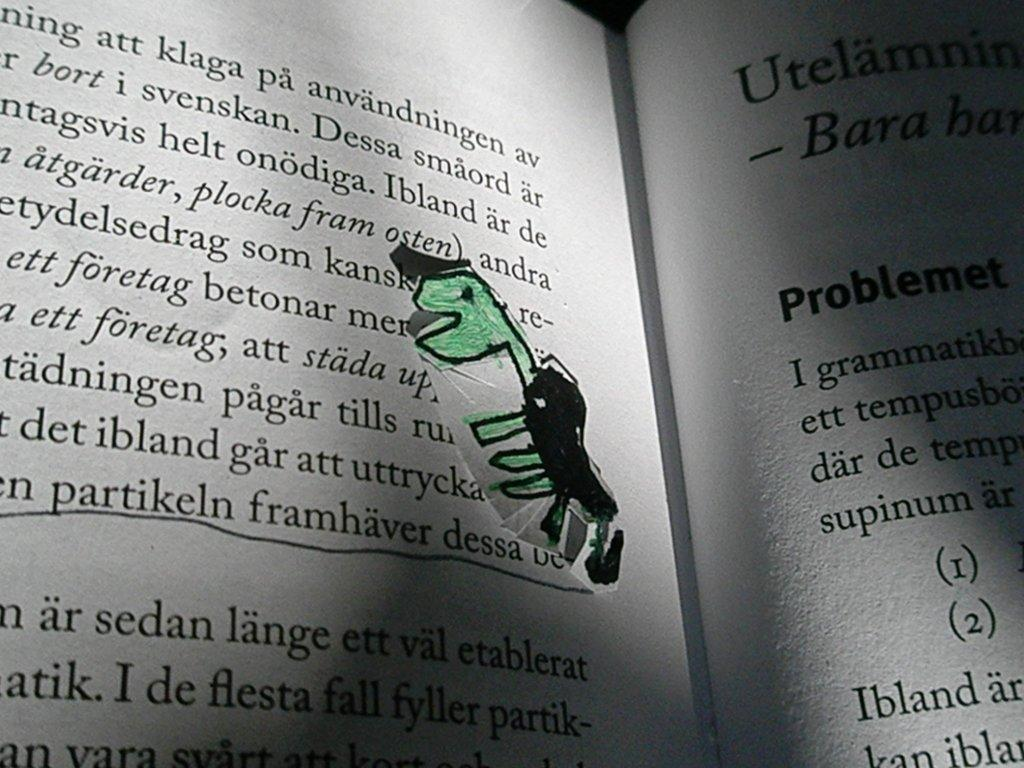<image>
Summarize the visual content of the image. the word foretag that is on a book page 